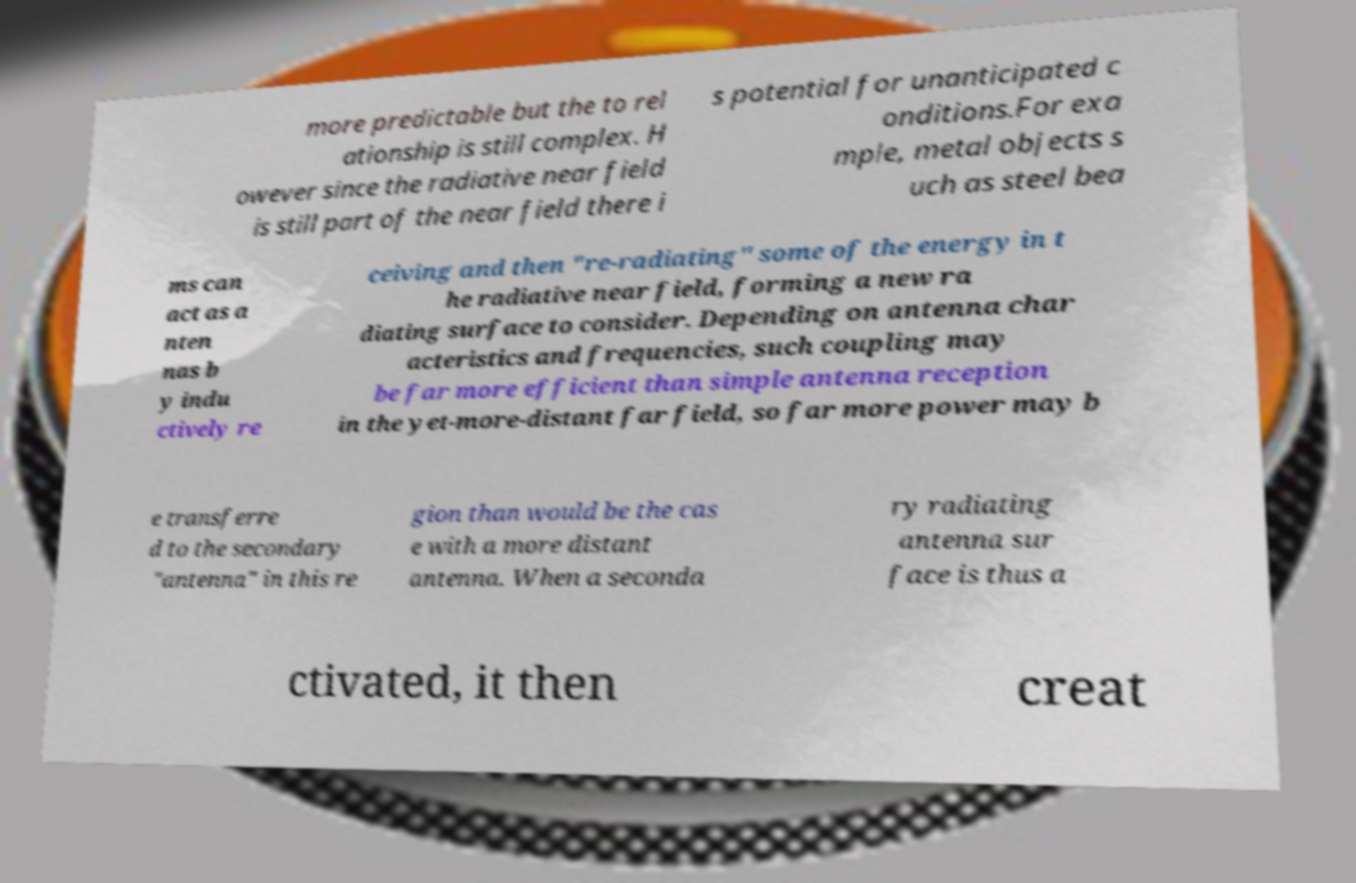For documentation purposes, I need the text within this image transcribed. Could you provide that? more predictable but the to rel ationship is still complex. H owever since the radiative near field is still part of the near field there i s potential for unanticipated c onditions.For exa mple, metal objects s uch as steel bea ms can act as a nten nas b y indu ctively re ceiving and then "re-radiating" some of the energy in t he radiative near field, forming a new ra diating surface to consider. Depending on antenna char acteristics and frequencies, such coupling may be far more efficient than simple antenna reception in the yet-more-distant far field, so far more power may b e transferre d to the secondary "antenna" in this re gion than would be the cas e with a more distant antenna. When a seconda ry radiating antenna sur face is thus a ctivated, it then creat 